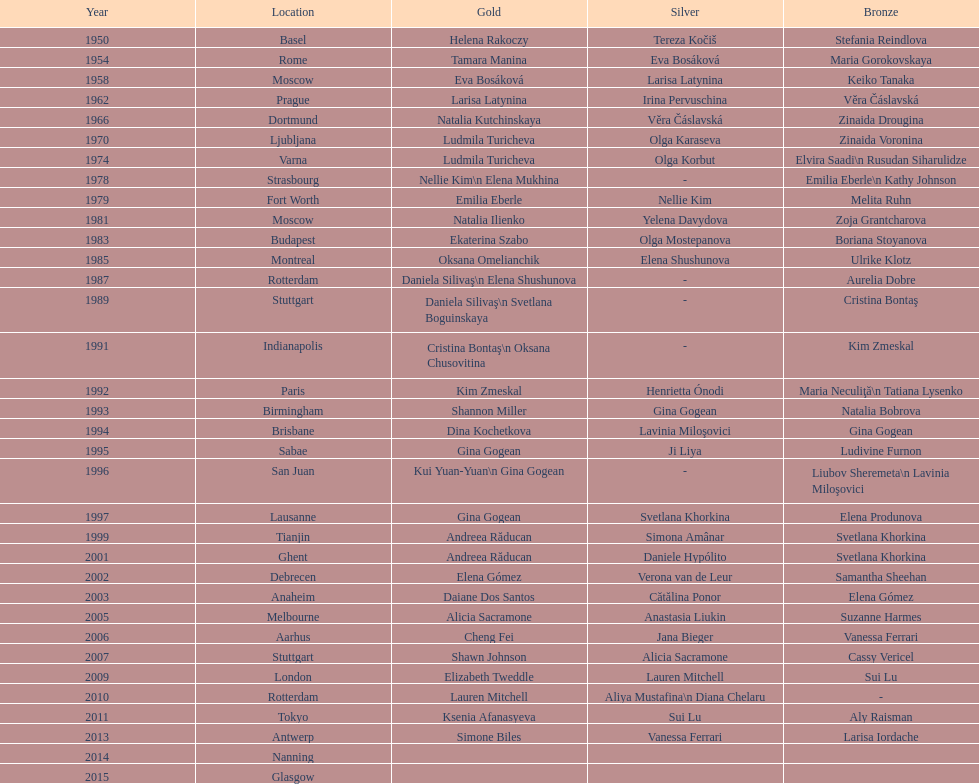Where were the championships held before the 1962 prague championships? Moscow. 